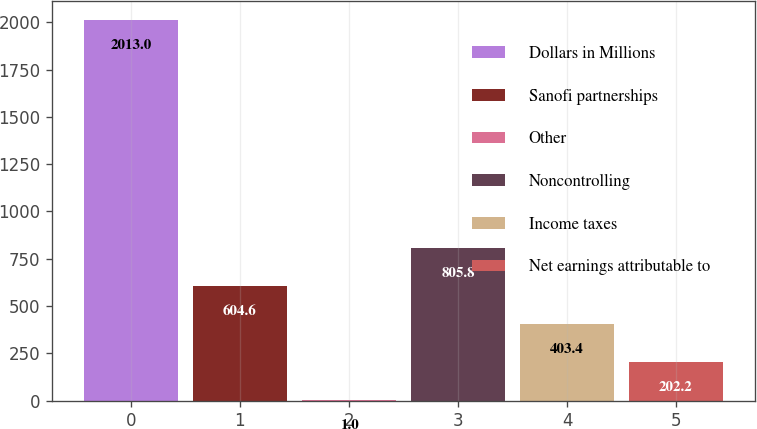<chart> <loc_0><loc_0><loc_500><loc_500><bar_chart><fcel>Dollars in Millions<fcel>Sanofi partnerships<fcel>Other<fcel>Noncontrolling<fcel>Income taxes<fcel>Net earnings attributable to<nl><fcel>2013<fcel>604.6<fcel>1<fcel>805.8<fcel>403.4<fcel>202.2<nl></chart> 